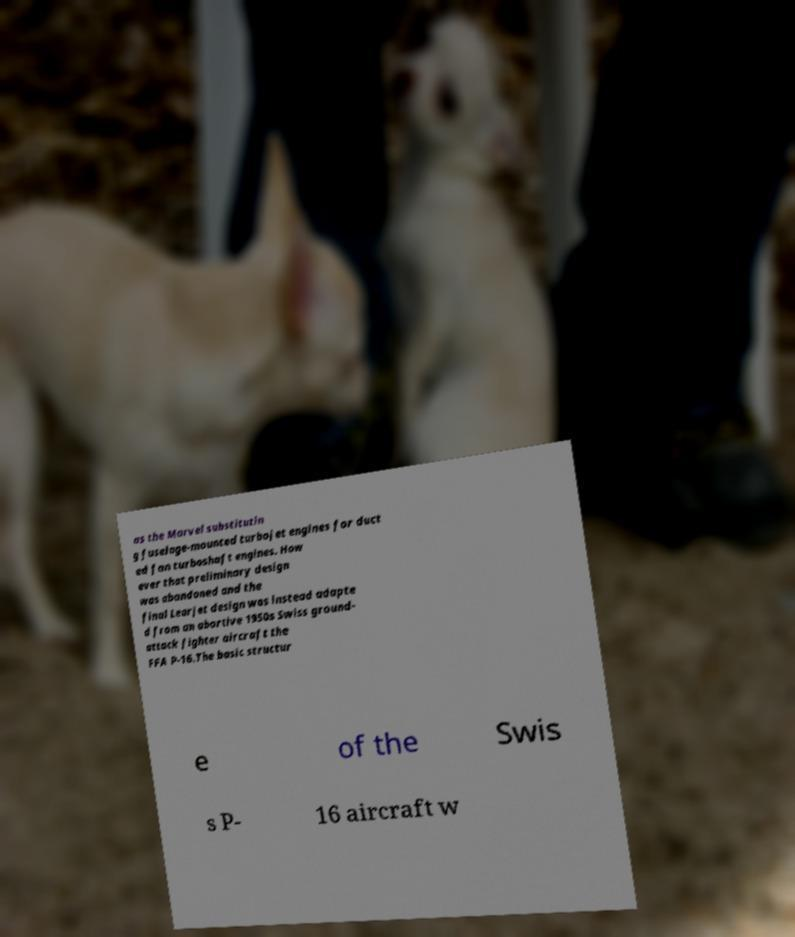Could you extract and type out the text from this image? as the Marvel substitutin g fuselage-mounted turbojet engines for duct ed fan turboshaft engines. How ever that preliminary design was abandoned and the final Learjet design was instead adapte d from an abortive 1950s Swiss ground- attack fighter aircraft the FFA P-16.The basic structur e of the Swis s P- 16 aircraft w 